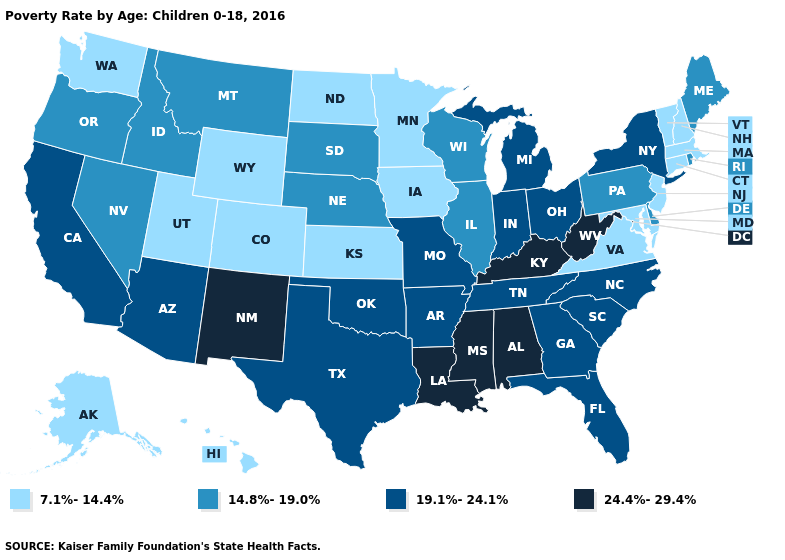Which states hav the highest value in the West?
Quick response, please. New Mexico. Among the states that border Nevada , does Utah have the lowest value?
Write a very short answer. Yes. Among the states that border South Dakota , does Nebraska have the highest value?
Be succinct. Yes. What is the value of South Dakota?
Quick response, please. 14.8%-19.0%. Among the states that border Texas , which have the lowest value?
Keep it brief. Arkansas, Oklahoma. What is the value of Tennessee?
Give a very brief answer. 19.1%-24.1%. Among the states that border Indiana , does Kentucky have the highest value?
Answer briefly. Yes. Does Illinois have the highest value in the MidWest?
Concise answer only. No. What is the value of South Dakota?
Short answer required. 14.8%-19.0%. What is the value of Iowa?
Short answer required. 7.1%-14.4%. Does the first symbol in the legend represent the smallest category?
Short answer required. Yes. What is the highest value in the USA?
Quick response, please. 24.4%-29.4%. Which states have the lowest value in the MidWest?
Answer briefly. Iowa, Kansas, Minnesota, North Dakota. What is the value of New York?
Give a very brief answer. 19.1%-24.1%. Name the states that have a value in the range 19.1%-24.1%?
Keep it brief. Arizona, Arkansas, California, Florida, Georgia, Indiana, Michigan, Missouri, New York, North Carolina, Ohio, Oklahoma, South Carolina, Tennessee, Texas. 